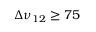<formula> <loc_0><loc_0><loc_500><loc_500>\Delta \nu _ { 1 2 } \geq 7 5</formula> 